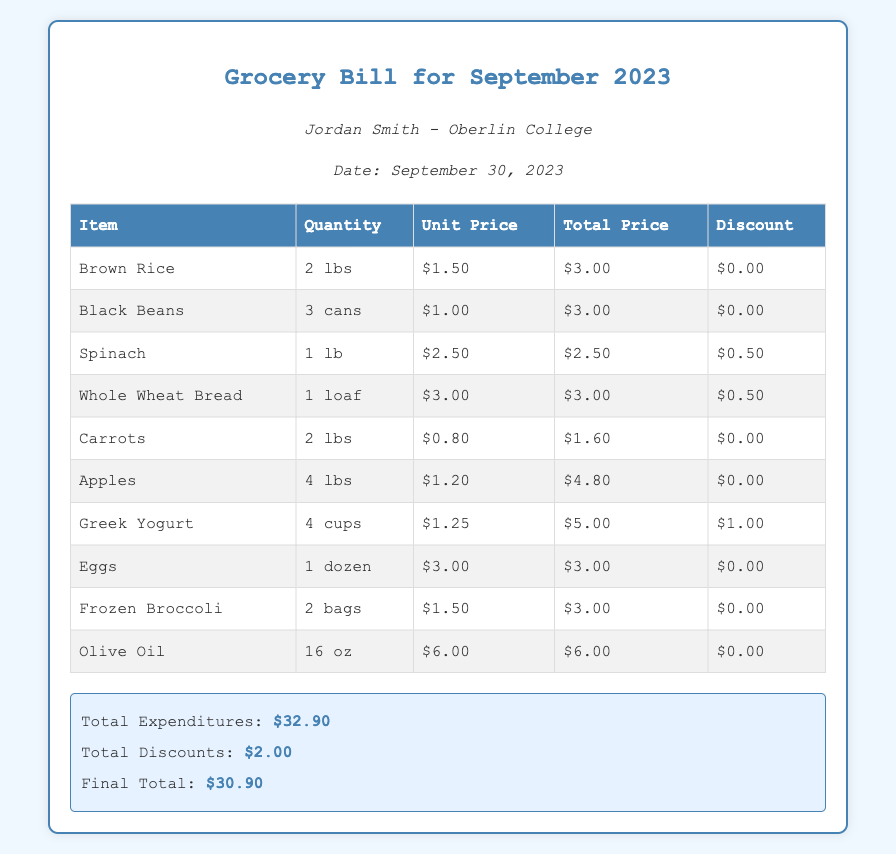What is the name of the student? Jordan Smith is mentioned as the student in the document.
Answer: Jordan Smith How many pounds of Spinach were purchased? The document indicates that 1 pound of Spinach was bought.
Answer: 1 lb What is the unit price of Black Beans? The unit price for Black Beans is given in the table as $1.00.
Answer: $1.00 What is the total expenditures for September 2023? The total expenditures listed in the summary of the document is $32.90.
Answer: $32.90 How much discount was applied to Greek Yogurt? The document specifies a $1.00 discount for Greek Yogurt.
Answer: $1.00 How many items were listed in the grocery bill? By counting the items in the table, there are a total of 10 items listed.
Answer: 10 What is the final total after discounts? The final total after applying discounts is stated as $30.90.
Answer: $30.90 What is the primary focus of this grocery bill? The grocery bill emphasizes healthy eating on a student budget.
Answer: Healthy eating How many cans of Black Beans were bought? The document shows that 3 cans of Black Beans were purchased.
Answer: 3 cans What month is this grocery bill for? The grocery bill explicitly states it is for September 2023.
Answer: September 2023 